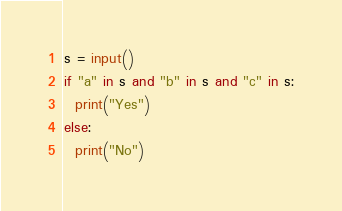Convert code to text. <code><loc_0><loc_0><loc_500><loc_500><_Python_>s = input()
if "a" in s and "b" in s and "c" in s:
  print("Yes")
else:
  print("No")</code> 